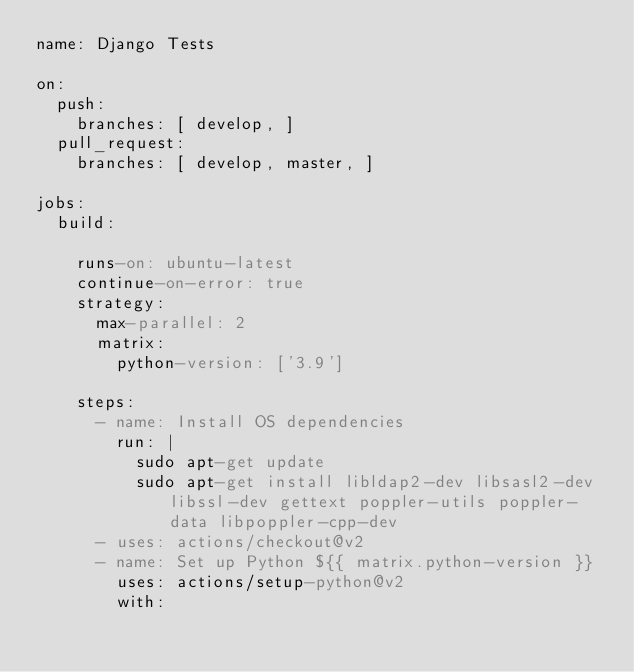Convert code to text. <code><loc_0><loc_0><loc_500><loc_500><_YAML_>name: Django Tests

on:
  push:
    branches: [ develop, ]
  pull_request:
    branches: [ develop, master, ]

jobs:
  build:

    runs-on: ubuntu-latest
    continue-on-error: true
    strategy:
      max-parallel: 2
      matrix:
        python-version: ['3.9']

    steps:
      - name: Install OS dependencies
        run: |
          sudo apt-get update
          sudo apt-get install libldap2-dev libsasl2-dev libssl-dev gettext poppler-utils poppler-data libpoppler-cpp-dev
      - uses: actions/checkout@v2
      - name: Set up Python ${{ matrix.python-version }}
        uses: actions/setup-python@v2
        with:</code> 